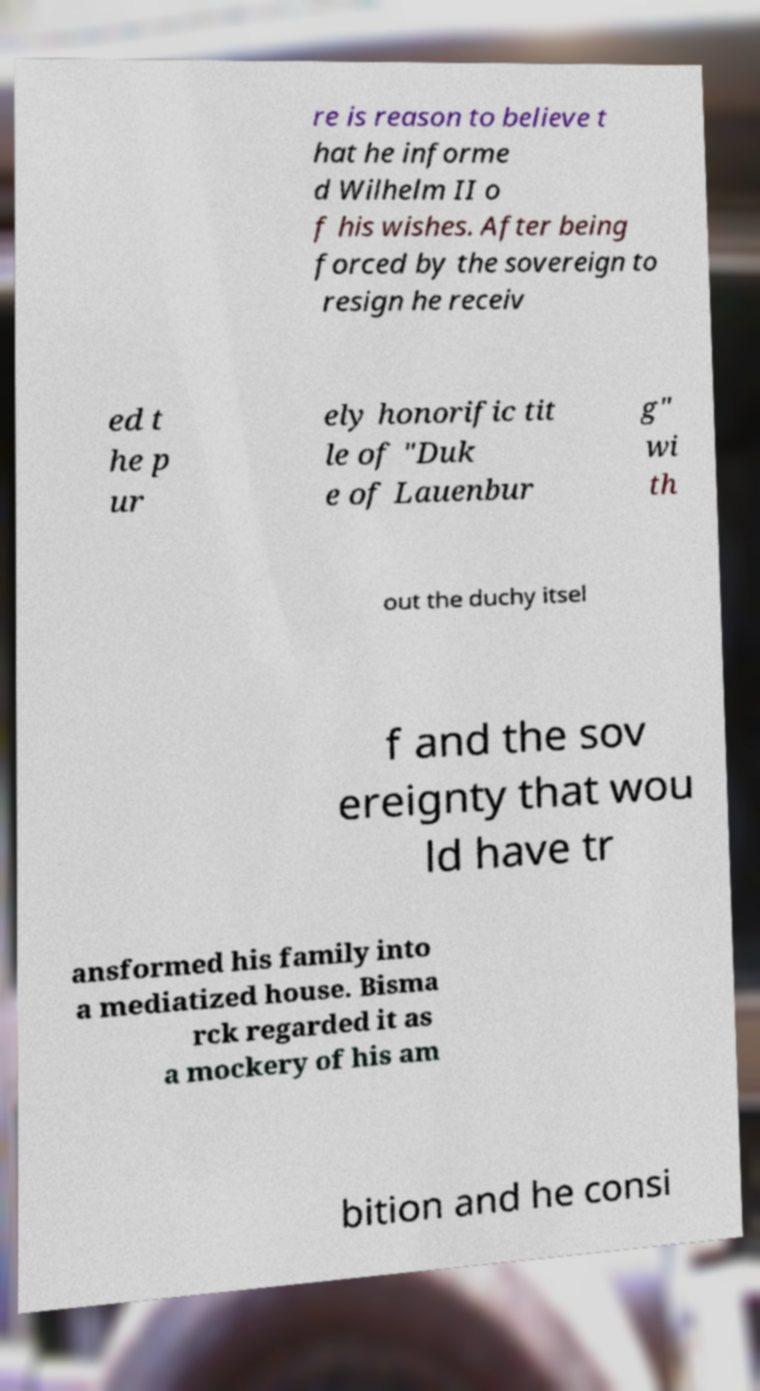Please read and relay the text visible in this image. What does it say? re is reason to believe t hat he informe d Wilhelm II o f his wishes. After being forced by the sovereign to resign he receiv ed t he p ur ely honorific tit le of "Duk e of Lauenbur g" wi th out the duchy itsel f and the sov ereignty that wou ld have tr ansformed his family into a mediatized house. Bisma rck regarded it as a mockery of his am bition and he consi 